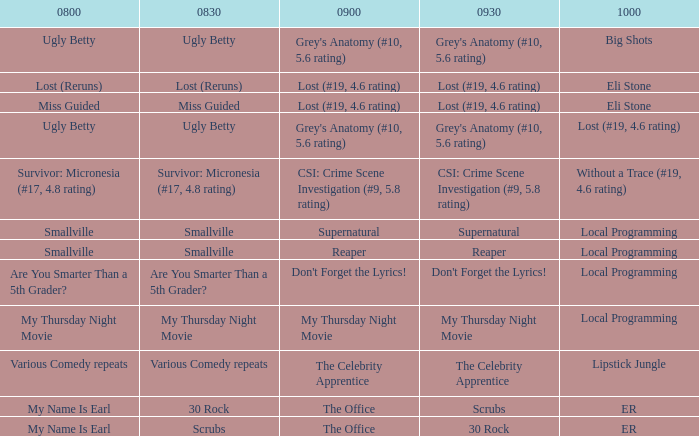What is at 10:00 when at 8:30 it is scrubs? ER. 